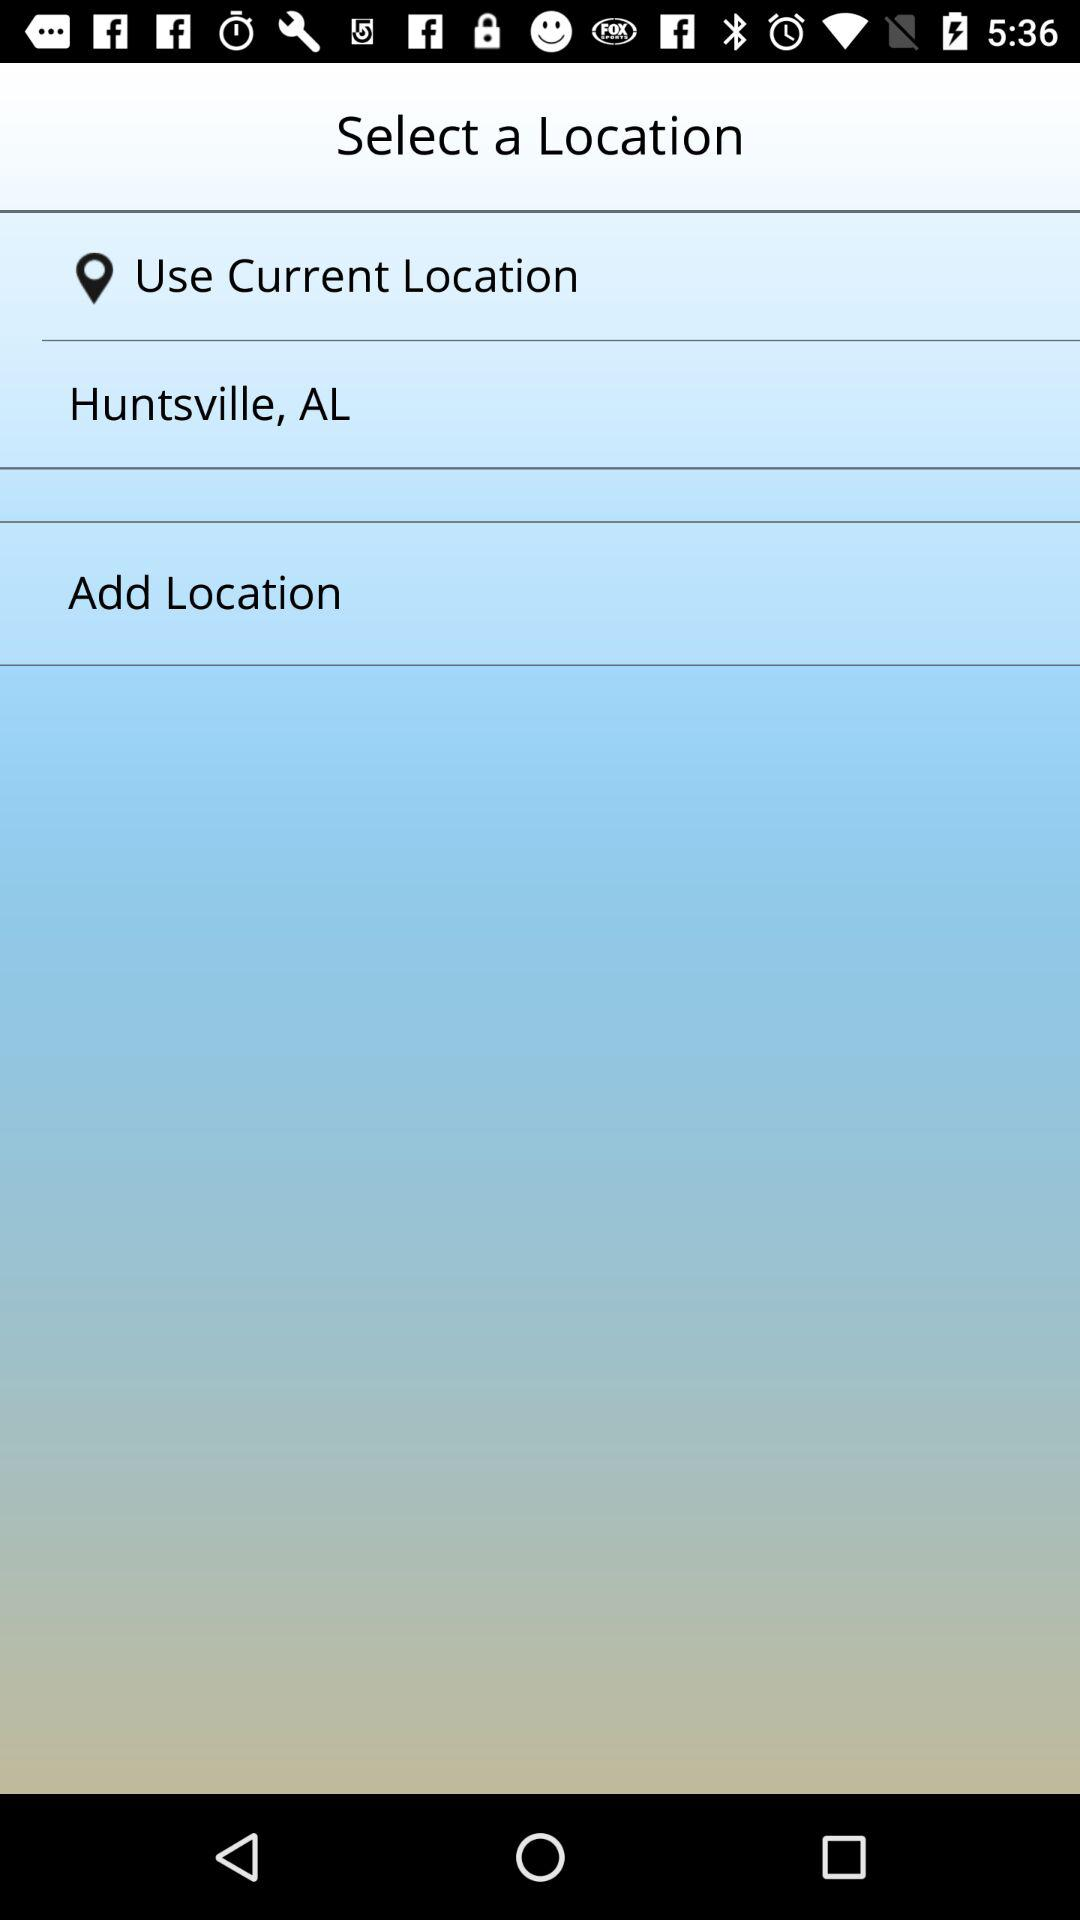Which locations are added?
When the provided information is insufficient, respond with <no answer>. <no answer> 